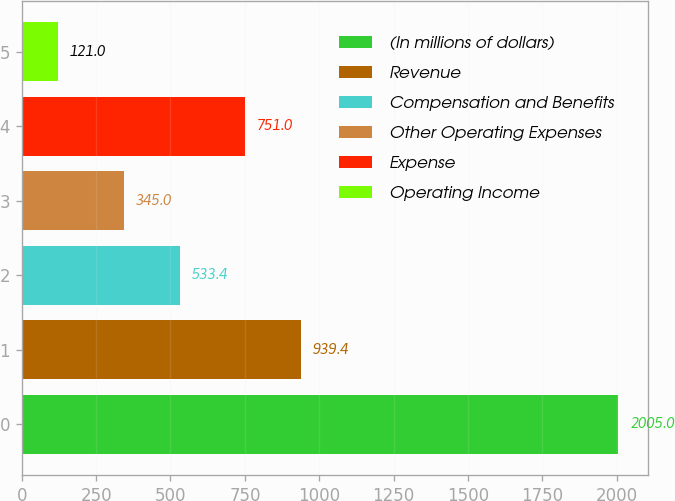<chart> <loc_0><loc_0><loc_500><loc_500><bar_chart><fcel>(In millions of dollars)<fcel>Revenue<fcel>Compensation and Benefits<fcel>Other Operating Expenses<fcel>Expense<fcel>Operating Income<nl><fcel>2005<fcel>939.4<fcel>533.4<fcel>345<fcel>751<fcel>121<nl></chart> 